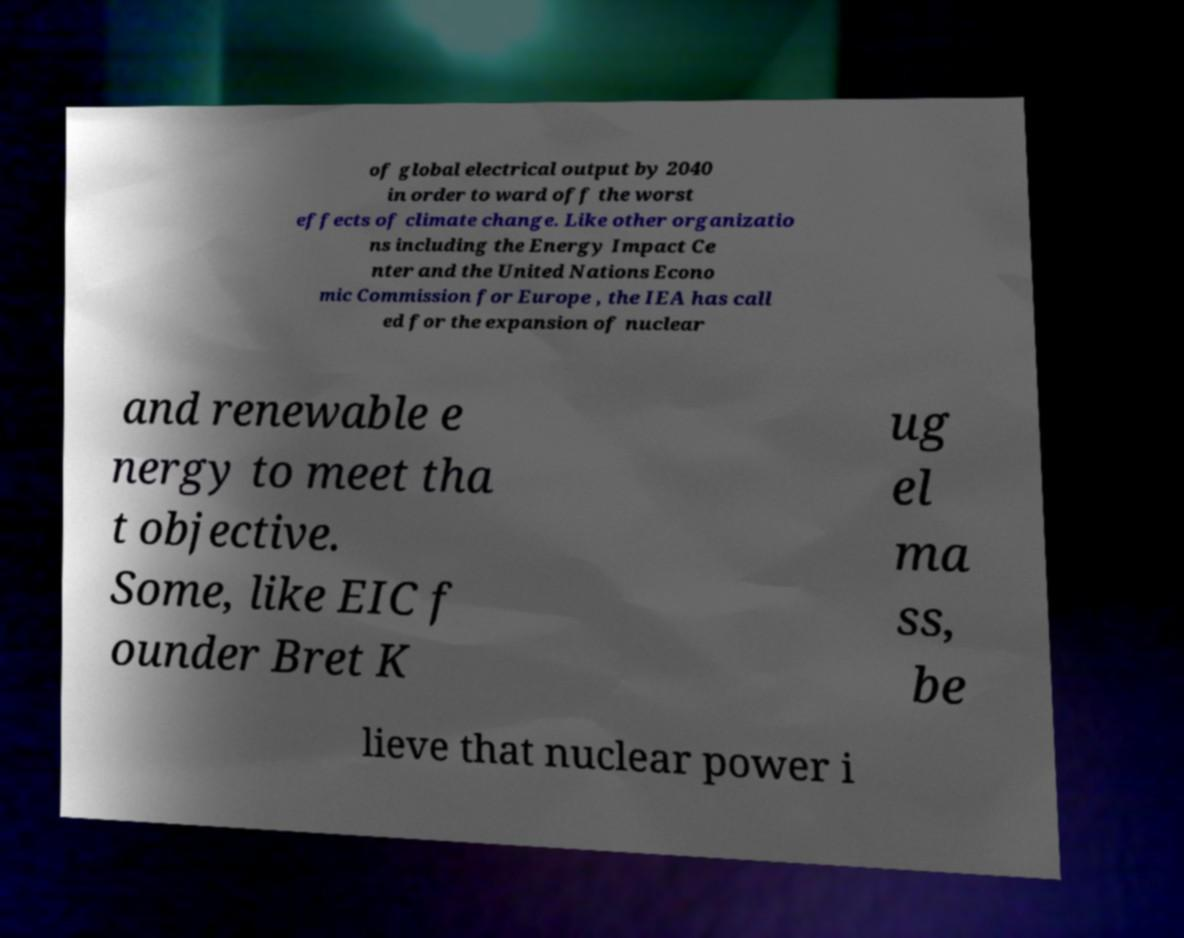For documentation purposes, I need the text within this image transcribed. Could you provide that? of global electrical output by 2040 in order to ward off the worst effects of climate change. Like other organizatio ns including the Energy Impact Ce nter and the United Nations Econo mic Commission for Europe , the IEA has call ed for the expansion of nuclear and renewable e nergy to meet tha t objective. Some, like EIC f ounder Bret K ug el ma ss, be lieve that nuclear power i 